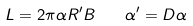<formula> <loc_0><loc_0><loc_500><loc_500>L = 2 \pi \alpha R ^ { \prime } B \quad \alpha ^ { \prime } = D \alpha</formula> 